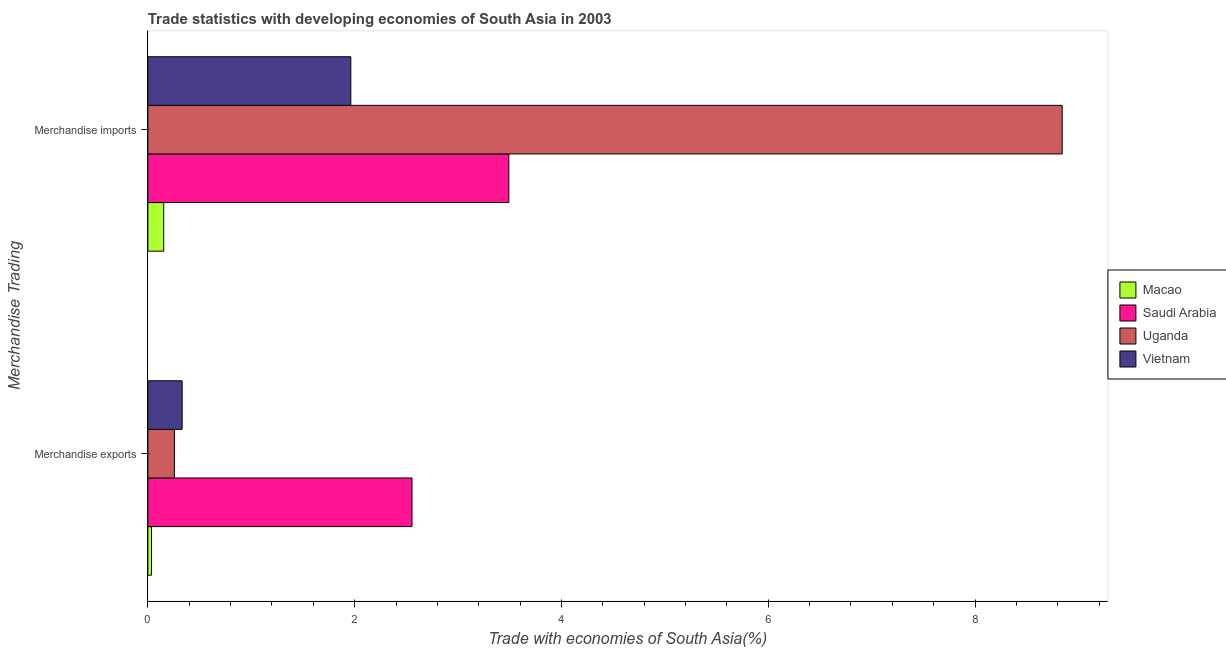How many groups of bars are there?
Ensure brevity in your answer.  2. Are the number of bars per tick equal to the number of legend labels?
Your answer should be compact. Yes. Are the number of bars on each tick of the Y-axis equal?
Ensure brevity in your answer.  Yes. How many bars are there on the 1st tick from the bottom?
Offer a very short reply. 4. What is the label of the 1st group of bars from the top?
Your response must be concise. Merchandise imports. What is the merchandise imports in Uganda?
Provide a succinct answer. 8.84. Across all countries, what is the maximum merchandise exports?
Give a very brief answer. 2.55. Across all countries, what is the minimum merchandise exports?
Give a very brief answer. 0.04. In which country was the merchandise imports maximum?
Provide a succinct answer. Uganda. In which country was the merchandise imports minimum?
Provide a short and direct response. Macao. What is the total merchandise exports in the graph?
Provide a succinct answer. 3.18. What is the difference between the merchandise imports in Macao and that in Vietnam?
Offer a very short reply. -1.81. What is the difference between the merchandise exports in Uganda and the merchandise imports in Vietnam?
Provide a short and direct response. -1.71. What is the average merchandise imports per country?
Your answer should be very brief. 3.61. What is the difference between the merchandise imports and merchandise exports in Saudi Arabia?
Your answer should be very brief. 0.94. In how many countries, is the merchandise exports greater than 5.2 %?
Provide a short and direct response. 0. What is the ratio of the merchandise imports in Macao to that in Vietnam?
Keep it short and to the point. 0.08. What does the 3rd bar from the top in Merchandise exports represents?
Your answer should be very brief. Saudi Arabia. What does the 2nd bar from the bottom in Merchandise exports represents?
Keep it short and to the point. Saudi Arabia. How many countries are there in the graph?
Ensure brevity in your answer.  4. Are the values on the major ticks of X-axis written in scientific E-notation?
Provide a succinct answer. No. How many legend labels are there?
Ensure brevity in your answer.  4. What is the title of the graph?
Give a very brief answer. Trade statistics with developing economies of South Asia in 2003. What is the label or title of the X-axis?
Ensure brevity in your answer.  Trade with economies of South Asia(%). What is the label or title of the Y-axis?
Provide a short and direct response. Merchandise Trading. What is the Trade with economies of South Asia(%) in Macao in Merchandise exports?
Offer a terse response. 0.04. What is the Trade with economies of South Asia(%) of Saudi Arabia in Merchandise exports?
Provide a short and direct response. 2.55. What is the Trade with economies of South Asia(%) in Uganda in Merchandise exports?
Ensure brevity in your answer.  0.26. What is the Trade with economies of South Asia(%) of Vietnam in Merchandise exports?
Provide a short and direct response. 0.33. What is the Trade with economies of South Asia(%) in Macao in Merchandise imports?
Offer a terse response. 0.15. What is the Trade with economies of South Asia(%) in Saudi Arabia in Merchandise imports?
Offer a very short reply. 3.49. What is the Trade with economies of South Asia(%) of Uganda in Merchandise imports?
Offer a very short reply. 8.84. What is the Trade with economies of South Asia(%) of Vietnam in Merchandise imports?
Provide a short and direct response. 1.96. Across all Merchandise Trading, what is the maximum Trade with economies of South Asia(%) of Macao?
Your answer should be compact. 0.15. Across all Merchandise Trading, what is the maximum Trade with economies of South Asia(%) of Saudi Arabia?
Provide a succinct answer. 3.49. Across all Merchandise Trading, what is the maximum Trade with economies of South Asia(%) in Uganda?
Your answer should be very brief. 8.84. Across all Merchandise Trading, what is the maximum Trade with economies of South Asia(%) in Vietnam?
Offer a terse response. 1.96. Across all Merchandise Trading, what is the minimum Trade with economies of South Asia(%) of Macao?
Offer a very short reply. 0.04. Across all Merchandise Trading, what is the minimum Trade with economies of South Asia(%) of Saudi Arabia?
Your response must be concise. 2.55. Across all Merchandise Trading, what is the minimum Trade with economies of South Asia(%) in Uganda?
Give a very brief answer. 0.26. Across all Merchandise Trading, what is the minimum Trade with economies of South Asia(%) in Vietnam?
Keep it short and to the point. 0.33. What is the total Trade with economies of South Asia(%) in Macao in the graph?
Provide a succinct answer. 0.19. What is the total Trade with economies of South Asia(%) in Saudi Arabia in the graph?
Your response must be concise. 6.05. What is the total Trade with economies of South Asia(%) in Uganda in the graph?
Offer a very short reply. 9.1. What is the total Trade with economies of South Asia(%) of Vietnam in the graph?
Ensure brevity in your answer.  2.29. What is the difference between the Trade with economies of South Asia(%) in Macao in Merchandise exports and that in Merchandise imports?
Provide a short and direct response. -0.12. What is the difference between the Trade with economies of South Asia(%) of Saudi Arabia in Merchandise exports and that in Merchandise imports?
Your answer should be very brief. -0.94. What is the difference between the Trade with economies of South Asia(%) in Uganda in Merchandise exports and that in Merchandise imports?
Your response must be concise. -8.59. What is the difference between the Trade with economies of South Asia(%) in Vietnam in Merchandise exports and that in Merchandise imports?
Keep it short and to the point. -1.63. What is the difference between the Trade with economies of South Asia(%) of Macao in Merchandise exports and the Trade with economies of South Asia(%) of Saudi Arabia in Merchandise imports?
Make the answer very short. -3.46. What is the difference between the Trade with economies of South Asia(%) in Macao in Merchandise exports and the Trade with economies of South Asia(%) in Uganda in Merchandise imports?
Give a very brief answer. -8.81. What is the difference between the Trade with economies of South Asia(%) of Macao in Merchandise exports and the Trade with economies of South Asia(%) of Vietnam in Merchandise imports?
Provide a succinct answer. -1.93. What is the difference between the Trade with economies of South Asia(%) in Saudi Arabia in Merchandise exports and the Trade with economies of South Asia(%) in Uganda in Merchandise imports?
Offer a very short reply. -6.29. What is the difference between the Trade with economies of South Asia(%) in Saudi Arabia in Merchandise exports and the Trade with economies of South Asia(%) in Vietnam in Merchandise imports?
Offer a terse response. 0.59. What is the difference between the Trade with economies of South Asia(%) in Uganda in Merchandise exports and the Trade with economies of South Asia(%) in Vietnam in Merchandise imports?
Offer a terse response. -1.71. What is the average Trade with economies of South Asia(%) of Macao per Merchandise Trading?
Provide a succinct answer. 0.09. What is the average Trade with economies of South Asia(%) of Saudi Arabia per Merchandise Trading?
Your answer should be compact. 3.02. What is the average Trade with economies of South Asia(%) of Uganda per Merchandise Trading?
Make the answer very short. 4.55. What is the average Trade with economies of South Asia(%) of Vietnam per Merchandise Trading?
Give a very brief answer. 1.15. What is the difference between the Trade with economies of South Asia(%) in Macao and Trade with economies of South Asia(%) in Saudi Arabia in Merchandise exports?
Your response must be concise. -2.52. What is the difference between the Trade with economies of South Asia(%) in Macao and Trade with economies of South Asia(%) in Uganda in Merchandise exports?
Your response must be concise. -0.22. What is the difference between the Trade with economies of South Asia(%) in Macao and Trade with economies of South Asia(%) in Vietnam in Merchandise exports?
Offer a terse response. -0.3. What is the difference between the Trade with economies of South Asia(%) of Saudi Arabia and Trade with economies of South Asia(%) of Uganda in Merchandise exports?
Your answer should be compact. 2.3. What is the difference between the Trade with economies of South Asia(%) in Saudi Arabia and Trade with economies of South Asia(%) in Vietnam in Merchandise exports?
Your answer should be compact. 2.22. What is the difference between the Trade with economies of South Asia(%) in Uganda and Trade with economies of South Asia(%) in Vietnam in Merchandise exports?
Ensure brevity in your answer.  -0.07. What is the difference between the Trade with economies of South Asia(%) in Macao and Trade with economies of South Asia(%) in Saudi Arabia in Merchandise imports?
Ensure brevity in your answer.  -3.34. What is the difference between the Trade with economies of South Asia(%) of Macao and Trade with economies of South Asia(%) of Uganda in Merchandise imports?
Ensure brevity in your answer.  -8.69. What is the difference between the Trade with economies of South Asia(%) in Macao and Trade with economies of South Asia(%) in Vietnam in Merchandise imports?
Your response must be concise. -1.81. What is the difference between the Trade with economies of South Asia(%) in Saudi Arabia and Trade with economies of South Asia(%) in Uganda in Merchandise imports?
Give a very brief answer. -5.35. What is the difference between the Trade with economies of South Asia(%) in Saudi Arabia and Trade with economies of South Asia(%) in Vietnam in Merchandise imports?
Provide a short and direct response. 1.53. What is the difference between the Trade with economies of South Asia(%) of Uganda and Trade with economies of South Asia(%) of Vietnam in Merchandise imports?
Keep it short and to the point. 6.88. What is the ratio of the Trade with economies of South Asia(%) in Macao in Merchandise exports to that in Merchandise imports?
Provide a short and direct response. 0.23. What is the ratio of the Trade with economies of South Asia(%) of Saudi Arabia in Merchandise exports to that in Merchandise imports?
Offer a very short reply. 0.73. What is the ratio of the Trade with economies of South Asia(%) of Uganda in Merchandise exports to that in Merchandise imports?
Keep it short and to the point. 0.03. What is the ratio of the Trade with economies of South Asia(%) in Vietnam in Merchandise exports to that in Merchandise imports?
Give a very brief answer. 0.17. What is the difference between the highest and the second highest Trade with economies of South Asia(%) in Macao?
Give a very brief answer. 0.12. What is the difference between the highest and the second highest Trade with economies of South Asia(%) in Saudi Arabia?
Provide a succinct answer. 0.94. What is the difference between the highest and the second highest Trade with economies of South Asia(%) in Uganda?
Give a very brief answer. 8.59. What is the difference between the highest and the second highest Trade with economies of South Asia(%) of Vietnam?
Offer a terse response. 1.63. What is the difference between the highest and the lowest Trade with economies of South Asia(%) of Macao?
Your response must be concise. 0.12. What is the difference between the highest and the lowest Trade with economies of South Asia(%) in Saudi Arabia?
Make the answer very short. 0.94. What is the difference between the highest and the lowest Trade with economies of South Asia(%) of Uganda?
Offer a terse response. 8.59. What is the difference between the highest and the lowest Trade with economies of South Asia(%) of Vietnam?
Your answer should be very brief. 1.63. 